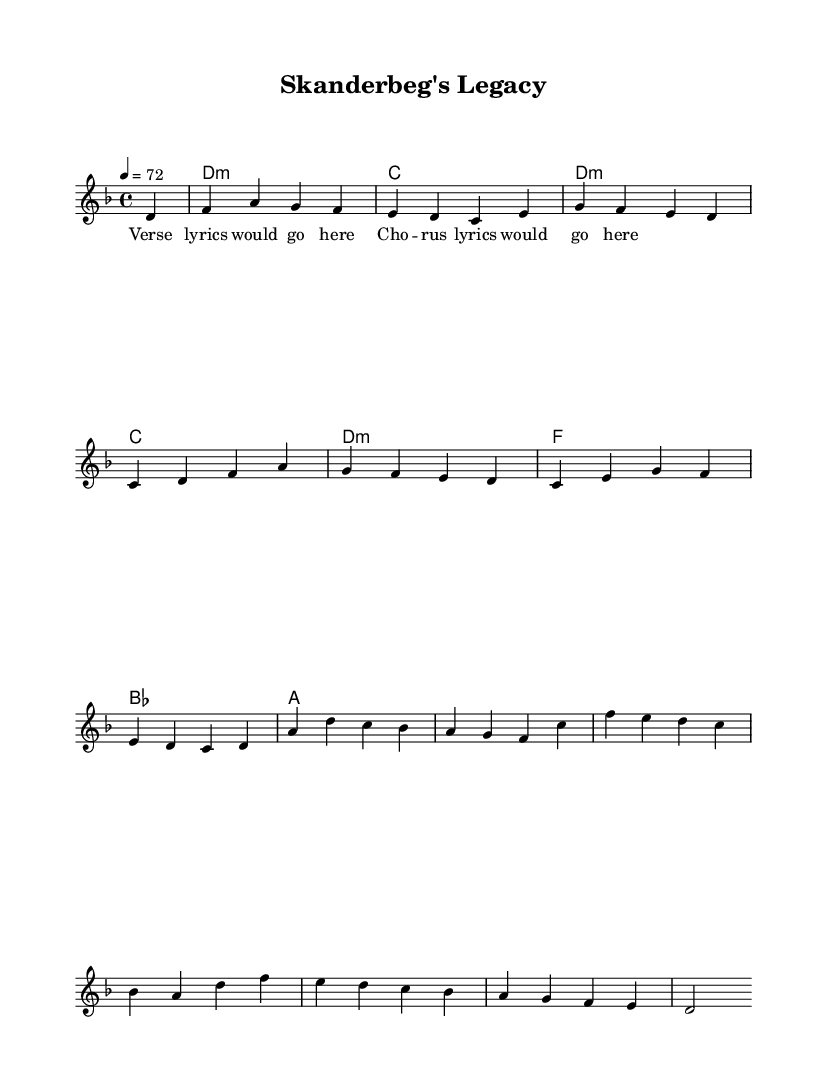What is the key signature of this music? The key signature is indicated at the beginning of the sheet music, and it shows two flats. This corresponds to the key of D minor.
Answer: D minor What is the time signature of this music? The time signature can be found at the start of the sheet music, denoted by the fraction 4/4, which means there are four beats in each measure and a quarter note receives one beat.
Answer: 4/4 What is the tempo marking of this music? The tempo marking is found within the global settings of the music, indicated as "4 = 72", meaning there are 72 beats per minute.
Answer: 72 How many measures are in the melody? The melody consists of individual phrases that can be counted by looking at the placement of the measure lines. There are a total of eight measures visible in the melody.
Answer: 8 What kind of musical influences does this piece exhibit? The piece is described as a folk-influenced rock ballad, integrating elements typical of folk music with a modern rock sensibility.
Answer: Folk-influenced rock What type of chords are used in the harmonies section? The harmonies section consists of various chord types which are indicated by the chord names. The predominant type seen is minor chords, along with major and seventh chords.
Answer: Minor and major chords What is the structure of the song in terms of lyrical content? The structure indicates there are verse lyrics followed by a chorus, signified in the score layout. The lyrics are assigned to different sections, showing the traditional verse-chorus format.
Answer: Verse and chorus 